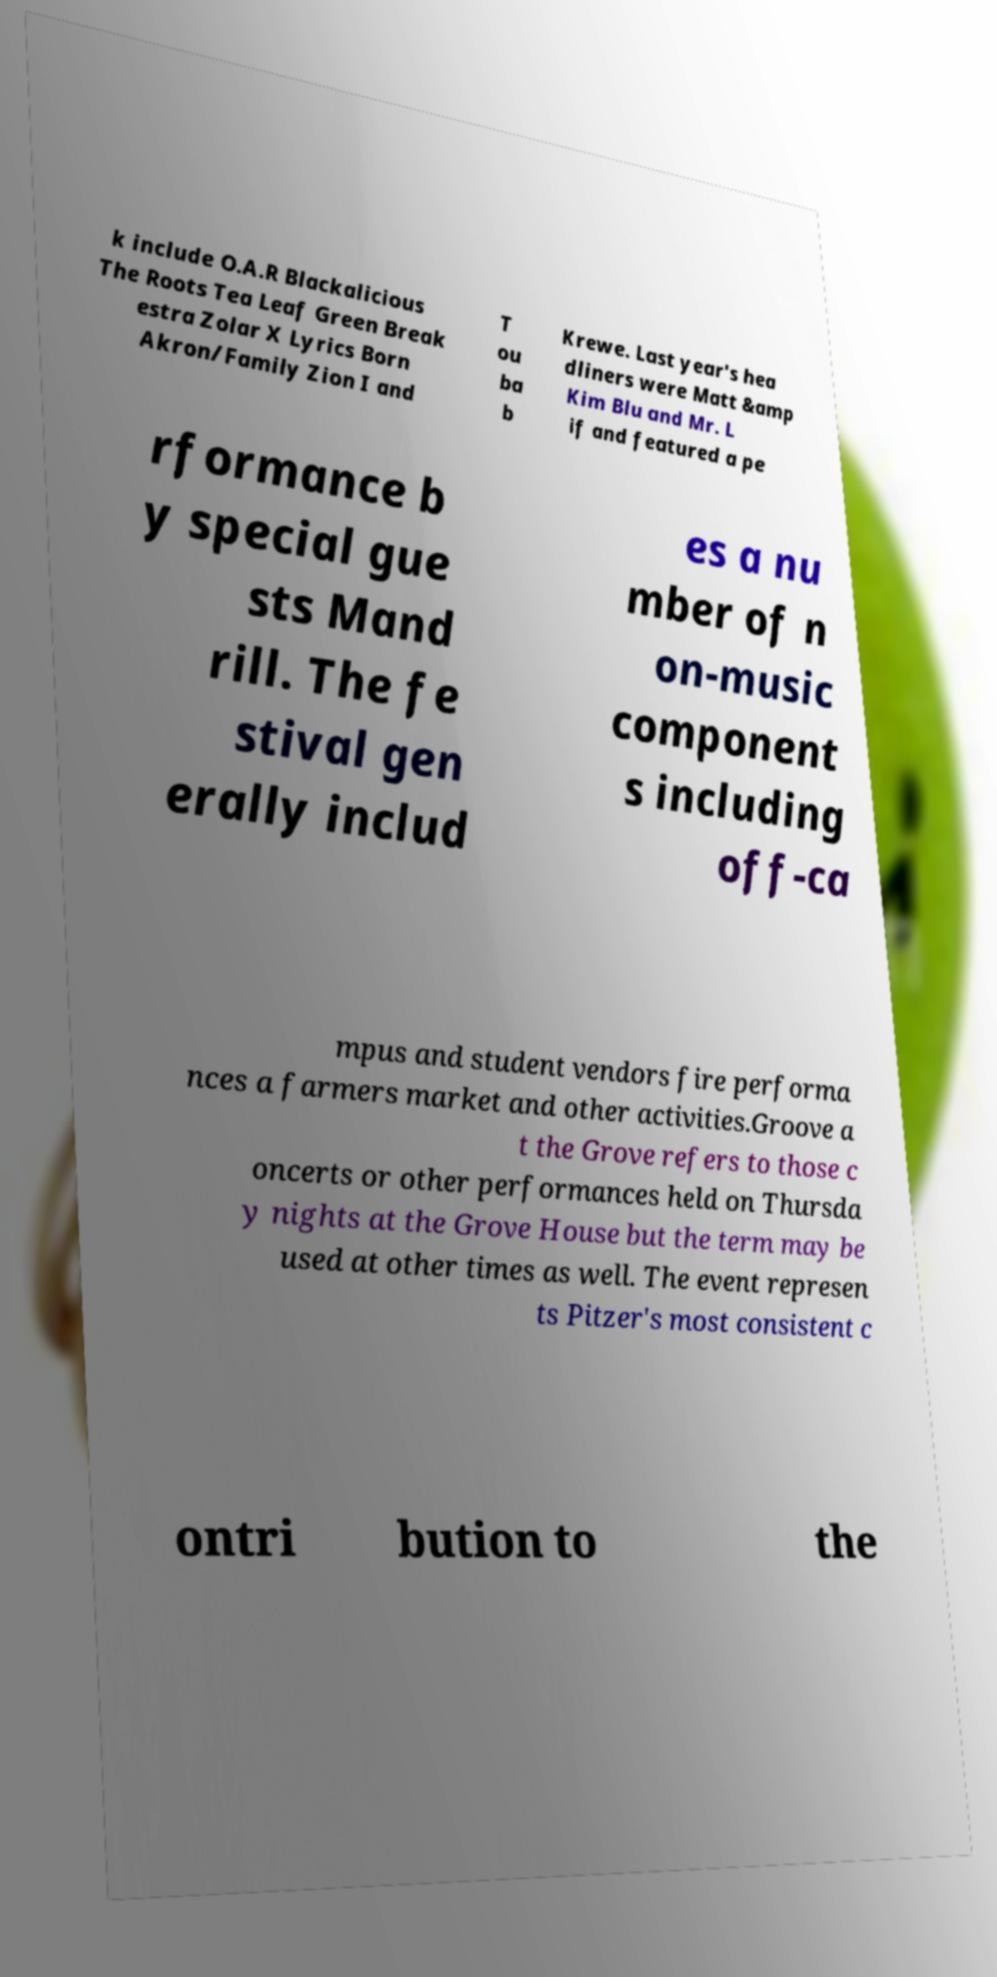Please identify and transcribe the text found in this image. k include O.A.R Blackalicious The Roots Tea Leaf Green Break estra Zolar X Lyrics Born Akron/Family Zion I and T ou ba b Krewe. Last year's hea dliners were Matt &amp Kim Blu and Mr. L if and featured a pe rformance b y special gue sts Mand rill. The fe stival gen erally includ es a nu mber of n on-music component s including off-ca mpus and student vendors fire performa nces a farmers market and other activities.Groove a t the Grove refers to those c oncerts or other performances held on Thursda y nights at the Grove House but the term may be used at other times as well. The event represen ts Pitzer's most consistent c ontri bution to the 